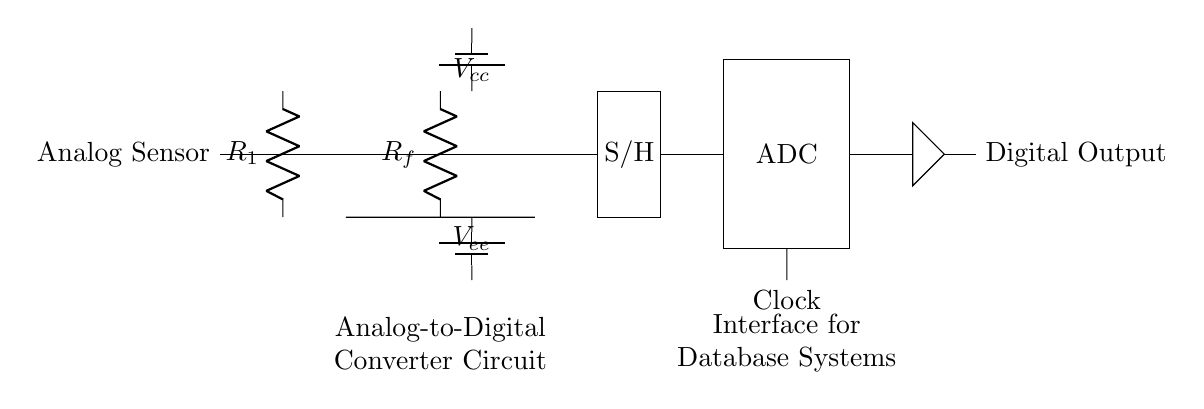What is the main function of the op-amp in this circuit? The op-amp amplifies the input signal from the analog sensor to ensure it's strong enough for the sampling and conversion process.
Answer: Amplification What component samples and holds the signal before conversion? The circuit includes a "Sample and Hold" block (S/H) that captures and holds the voltage level of the signal for accurate conversion by the ADC.
Answer: Sample and Hold How many distinct voltage supplies are present in the circuit? The circuit shows a positive voltage supply (\(V_{cc}\)) and a negative voltage supply (\(V_{ee}\)), indicating two distinct voltage supplies are used to power the op-amp and other components.
Answer: Two What does the ADC in the circuit signify? The ADC (Analog-to-Digital Converter) is responsible for converting the amplified and held analog voltage into a digital format that can be processed by a digital system or database.
Answer: Analog-to-Digital Converter What is the significance of the clock in this circuit? The clock provides timing signals necessary for the operation of the ADC, ensuring that conversion processes are synchronized at specific intervals.
Answer: Timing signals Which element directly interfaces with the digital database system? The Digital Output from the ADC directly sends the converted digital signals to the digital database system for processing and storage.
Answer: Digital Output 